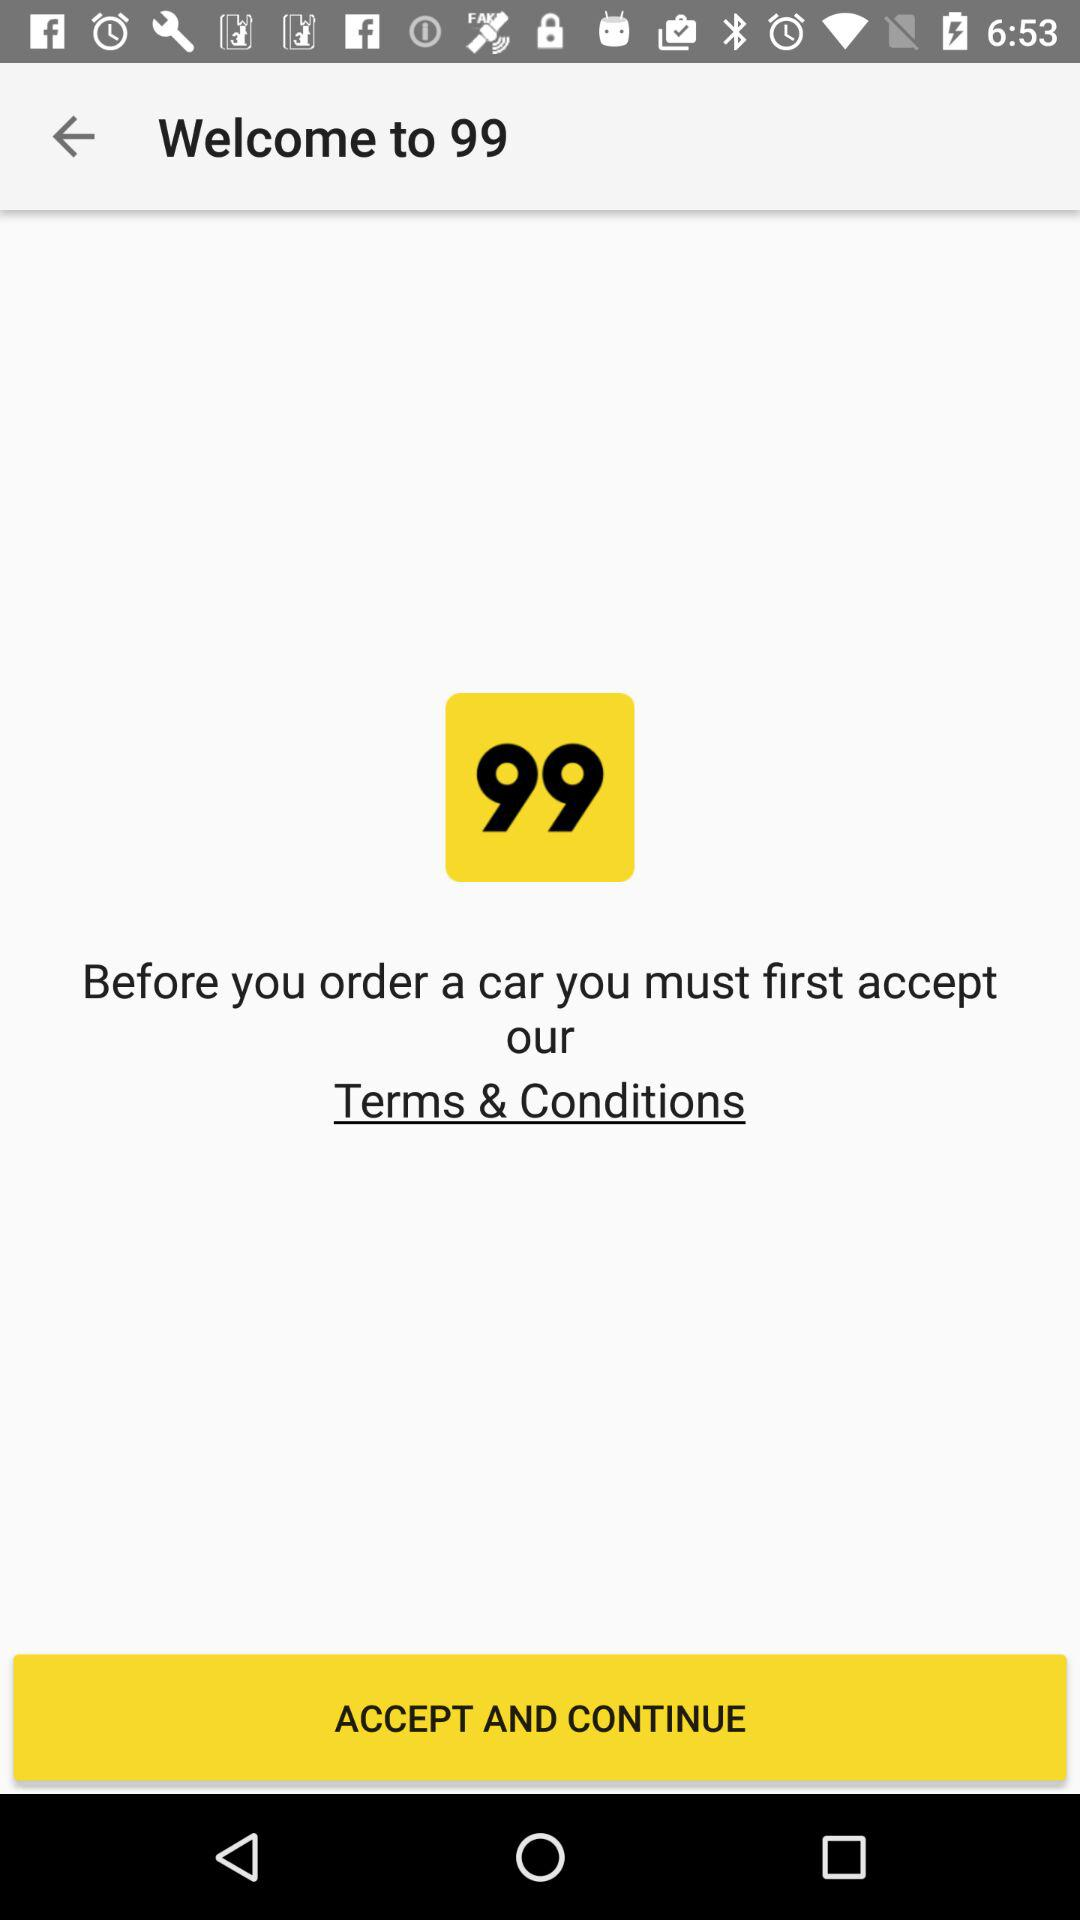Has the user agreed to the terms and conditions?
When the provided information is insufficient, respond with <no answer>. <no answer> 